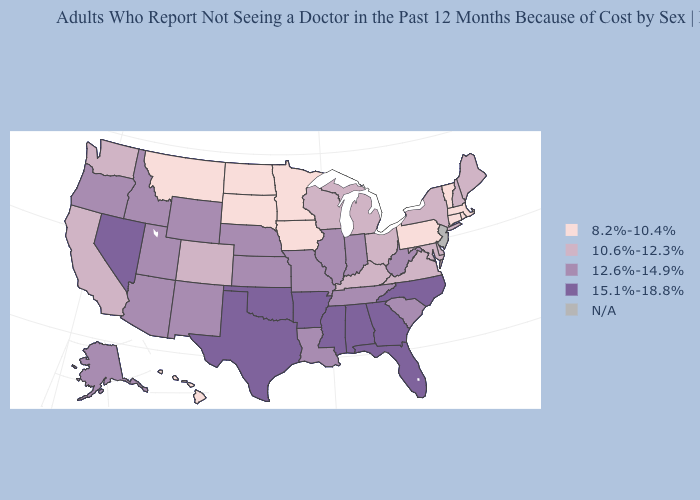Among the states that border Nevada , which have the highest value?
Write a very short answer. Arizona, Idaho, Oregon, Utah. Among the states that border Washington , which have the highest value?
Quick response, please. Idaho, Oregon. Which states have the lowest value in the MidWest?
Give a very brief answer. Iowa, Minnesota, North Dakota, South Dakota. Among the states that border Florida , which have the lowest value?
Quick response, please. Alabama, Georgia. Which states have the lowest value in the West?
Short answer required. Hawaii, Montana. Name the states that have a value in the range 8.2%-10.4%?
Write a very short answer. Connecticut, Hawaii, Iowa, Massachusetts, Minnesota, Montana, North Dakota, Pennsylvania, Rhode Island, South Dakota, Vermont. Does the first symbol in the legend represent the smallest category?
Short answer required. Yes. What is the value of Alaska?
Quick response, please. 12.6%-14.9%. Name the states that have a value in the range 10.6%-12.3%?
Keep it brief. California, Colorado, Delaware, Kentucky, Maine, Maryland, Michigan, New Hampshire, New York, Ohio, Virginia, Washington, Wisconsin. What is the value of New Hampshire?
Be succinct. 10.6%-12.3%. What is the value of New Jersey?
Quick response, please. N/A. Does Montana have the lowest value in the West?
Write a very short answer. Yes. What is the value of Delaware?
Short answer required. 10.6%-12.3%. Does North Dakota have the highest value in the MidWest?
Be succinct. No. 